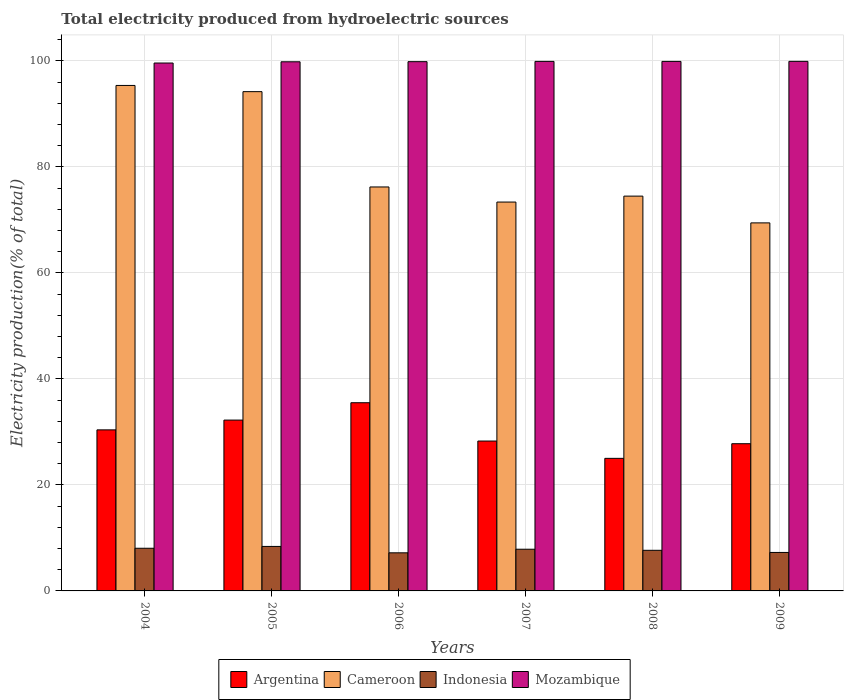How many groups of bars are there?
Make the answer very short. 6. Are the number of bars per tick equal to the number of legend labels?
Offer a terse response. Yes. How many bars are there on the 3rd tick from the left?
Provide a succinct answer. 4. How many bars are there on the 5th tick from the right?
Your response must be concise. 4. What is the label of the 3rd group of bars from the left?
Your answer should be compact. 2006. In how many cases, is the number of bars for a given year not equal to the number of legend labels?
Keep it short and to the point. 0. What is the total electricity produced in Mozambique in 2009?
Ensure brevity in your answer.  99.92. Across all years, what is the maximum total electricity produced in Indonesia?
Your answer should be very brief. 8.4. Across all years, what is the minimum total electricity produced in Argentina?
Your answer should be compact. 25.01. What is the total total electricity produced in Argentina in the graph?
Offer a terse response. 179.21. What is the difference between the total electricity produced in Mozambique in 2004 and that in 2007?
Keep it short and to the point. -0.31. What is the difference between the total electricity produced in Argentina in 2006 and the total electricity produced in Mozambique in 2004?
Ensure brevity in your answer.  -64.1. What is the average total electricity produced in Cameroon per year?
Ensure brevity in your answer.  80.52. In the year 2004, what is the difference between the total electricity produced in Mozambique and total electricity produced in Cameroon?
Provide a succinct answer. 4.23. In how many years, is the total electricity produced in Cameroon greater than 76 %?
Your response must be concise. 3. What is the ratio of the total electricity produced in Argentina in 2004 to that in 2008?
Your answer should be compact. 1.21. Is the total electricity produced in Cameroon in 2005 less than that in 2008?
Ensure brevity in your answer.  No. What is the difference between the highest and the second highest total electricity produced in Indonesia?
Provide a short and direct response. 0.35. What is the difference between the highest and the lowest total electricity produced in Argentina?
Your answer should be very brief. 10.5. In how many years, is the total electricity produced in Indonesia greater than the average total electricity produced in Indonesia taken over all years?
Your answer should be compact. 3. Is the sum of the total electricity produced in Cameroon in 2005 and 2008 greater than the maximum total electricity produced in Mozambique across all years?
Offer a very short reply. Yes. What does the 2nd bar from the left in 2005 represents?
Ensure brevity in your answer.  Cameroon. What does the 1st bar from the right in 2005 represents?
Your answer should be compact. Mozambique. Is it the case that in every year, the sum of the total electricity produced in Mozambique and total electricity produced in Indonesia is greater than the total electricity produced in Cameroon?
Give a very brief answer. Yes. How many bars are there?
Ensure brevity in your answer.  24. Are all the bars in the graph horizontal?
Make the answer very short. No. How many years are there in the graph?
Keep it short and to the point. 6. What is the difference between two consecutive major ticks on the Y-axis?
Give a very brief answer. 20. Are the values on the major ticks of Y-axis written in scientific E-notation?
Your answer should be compact. No. Where does the legend appear in the graph?
Your answer should be very brief. Bottom center. How are the legend labels stacked?
Offer a terse response. Horizontal. What is the title of the graph?
Your answer should be very brief. Total electricity produced from hydroelectric sources. What is the label or title of the Y-axis?
Provide a short and direct response. Electricity production(% of total). What is the Electricity production(% of total) of Argentina in 2004?
Ensure brevity in your answer.  30.39. What is the Electricity production(% of total) in Cameroon in 2004?
Make the answer very short. 95.38. What is the Electricity production(% of total) in Indonesia in 2004?
Provide a succinct answer. 8.05. What is the Electricity production(% of total) in Mozambique in 2004?
Give a very brief answer. 99.61. What is the Electricity production(% of total) of Argentina in 2005?
Provide a short and direct response. 32.23. What is the Electricity production(% of total) in Cameroon in 2005?
Your response must be concise. 94.21. What is the Electricity production(% of total) of Indonesia in 2005?
Your response must be concise. 8.4. What is the Electricity production(% of total) in Mozambique in 2005?
Offer a very short reply. 99.84. What is the Electricity production(% of total) in Argentina in 2006?
Your answer should be compact. 35.51. What is the Electricity production(% of total) of Cameroon in 2006?
Your response must be concise. 76.22. What is the Electricity production(% of total) of Indonesia in 2006?
Ensure brevity in your answer.  7.19. What is the Electricity production(% of total) in Mozambique in 2006?
Ensure brevity in your answer.  99.86. What is the Electricity production(% of total) in Argentina in 2007?
Your answer should be very brief. 28.28. What is the Electricity production(% of total) of Cameroon in 2007?
Offer a very short reply. 73.37. What is the Electricity production(% of total) of Indonesia in 2007?
Ensure brevity in your answer.  7.87. What is the Electricity production(% of total) in Mozambique in 2007?
Make the answer very short. 99.92. What is the Electricity production(% of total) in Argentina in 2008?
Provide a succinct answer. 25.01. What is the Electricity production(% of total) in Cameroon in 2008?
Provide a succinct answer. 74.49. What is the Electricity production(% of total) in Indonesia in 2008?
Provide a short and direct response. 7.66. What is the Electricity production(% of total) in Mozambique in 2008?
Provide a succinct answer. 99.91. What is the Electricity production(% of total) of Argentina in 2009?
Provide a succinct answer. 27.78. What is the Electricity production(% of total) in Cameroon in 2009?
Offer a very short reply. 69.44. What is the Electricity production(% of total) of Indonesia in 2009?
Your answer should be compact. 7.26. What is the Electricity production(% of total) in Mozambique in 2009?
Your answer should be compact. 99.92. Across all years, what is the maximum Electricity production(% of total) in Argentina?
Provide a succinct answer. 35.51. Across all years, what is the maximum Electricity production(% of total) of Cameroon?
Give a very brief answer. 95.38. Across all years, what is the maximum Electricity production(% of total) in Indonesia?
Give a very brief answer. 8.4. Across all years, what is the maximum Electricity production(% of total) in Mozambique?
Keep it short and to the point. 99.92. Across all years, what is the minimum Electricity production(% of total) of Argentina?
Your answer should be very brief. 25.01. Across all years, what is the minimum Electricity production(% of total) in Cameroon?
Provide a succinct answer. 69.44. Across all years, what is the minimum Electricity production(% of total) in Indonesia?
Offer a terse response. 7.19. Across all years, what is the minimum Electricity production(% of total) in Mozambique?
Offer a very short reply. 99.61. What is the total Electricity production(% of total) in Argentina in the graph?
Your answer should be compact. 179.21. What is the total Electricity production(% of total) of Cameroon in the graph?
Keep it short and to the point. 483.12. What is the total Electricity production(% of total) of Indonesia in the graph?
Provide a succinct answer. 46.43. What is the total Electricity production(% of total) of Mozambique in the graph?
Your response must be concise. 599.07. What is the difference between the Electricity production(% of total) of Argentina in 2004 and that in 2005?
Your answer should be very brief. -1.84. What is the difference between the Electricity production(% of total) in Cameroon in 2004 and that in 2005?
Your response must be concise. 1.17. What is the difference between the Electricity production(% of total) in Indonesia in 2004 and that in 2005?
Provide a succinct answer. -0.34. What is the difference between the Electricity production(% of total) in Mozambique in 2004 and that in 2005?
Provide a succinct answer. -0.23. What is the difference between the Electricity production(% of total) of Argentina in 2004 and that in 2006?
Make the answer very short. -5.12. What is the difference between the Electricity production(% of total) of Cameroon in 2004 and that in 2006?
Provide a short and direct response. 19.15. What is the difference between the Electricity production(% of total) in Indonesia in 2004 and that in 2006?
Ensure brevity in your answer.  0.86. What is the difference between the Electricity production(% of total) in Mozambique in 2004 and that in 2006?
Your answer should be compact. -0.26. What is the difference between the Electricity production(% of total) in Argentina in 2004 and that in 2007?
Provide a short and direct response. 2.11. What is the difference between the Electricity production(% of total) of Cameroon in 2004 and that in 2007?
Your answer should be very brief. 22. What is the difference between the Electricity production(% of total) in Indonesia in 2004 and that in 2007?
Your answer should be compact. 0.18. What is the difference between the Electricity production(% of total) of Mozambique in 2004 and that in 2007?
Your answer should be compact. -0.31. What is the difference between the Electricity production(% of total) in Argentina in 2004 and that in 2008?
Offer a terse response. 5.38. What is the difference between the Electricity production(% of total) of Cameroon in 2004 and that in 2008?
Provide a short and direct response. 20.88. What is the difference between the Electricity production(% of total) in Indonesia in 2004 and that in 2008?
Give a very brief answer. 0.39. What is the difference between the Electricity production(% of total) of Mozambique in 2004 and that in 2008?
Provide a succinct answer. -0.31. What is the difference between the Electricity production(% of total) in Argentina in 2004 and that in 2009?
Keep it short and to the point. 2.61. What is the difference between the Electricity production(% of total) of Cameroon in 2004 and that in 2009?
Offer a terse response. 25.93. What is the difference between the Electricity production(% of total) of Indonesia in 2004 and that in 2009?
Ensure brevity in your answer.  0.79. What is the difference between the Electricity production(% of total) in Mozambique in 2004 and that in 2009?
Provide a succinct answer. -0.32. What is the difference between the Electricity production(% of total) of Argentina in 2005 and that in 2006?
Keep it short and to the point. -3.28. What is the difference between the Electricity production(% of total) in Cameroon in 2005 and that in 2006?
Offer a terse response. 17.98. What is the difference between the Electricity production(% of total) in Indonesia in 2005 and that in 2006?
Offer a terse response. 1.21. What is the difference between the Electricity production(% of total) in Mozambique in 2005 and that in 2006?
Ensure brevity in your answer.  -0.02. What is the difference between the Electricity production(% of total) in Argentina in 2005 and that in 2007?
Make the answer very short. 3.95. What is the difference between the Electricity production(% of total) in Cameroon in 2005 and that in 2007?
Ensure brevity in your answer.  20.83. What is the difference between the Electricity production(% of total) of Indonesia in 2005 and that in 2007?
Your response must be concise. 0.53. What is the difference between the Electricity production(% of total) of Mozambique in 2005 and that in 2007?
Keep it short and to the point. -0.08. What is the difference between the Electricity production(% of total) of Argentina in 2005 and that in 2008?
Give a very brief answer. 7.22. What is the difference between the Electricity production(% of total) in Cameroon in 2005 and that in 2008?
Keep it short and to the point. 19.71. What is the difference between the Electricity production(% of total) in Indonesia in 2005 and that in 2008?
Ensure brevity in your answer.  0.73. What is the difference between the Electricity production(% of total) of Mozambique in 2005 and that in 2008?
Offer a terse response. -0.07. What is the difference between the Electricity production(% of total) in Argentina in 2005 and that in 2009?
Your answer should be compact. 4.46. What is the difference between the Electricity production(% of total) of Cameroon in 2005 and that in 2009?
Provide a succinct answer. 24.76. What is the difference between the Electricity production(% of total) in Indonesia in 2005 and that in 2009?
Provide a succinct answer. 1.14. What is the difference between the Electricity production(% of total) of Mozambique in 2005 and that in 2009?
Keep it short and to the point. -0.08. What is the difference between the Electricity production(% of total) in Argentina in 2006 and that in 2007?
Your answer should be very brief. 7.23. What is the difference between the Electricity production(% of total) in Cameroon in 2006 and that in 2007?
Offer a very short reply. 2.85. What is the difference between the Electricity production(% of total) of Indonesia in 2006 and that in 2007?
Give a very brief answer. -0.68. What is the difference between the Electricity production(% of total) of Mozambique in 2006 and that in 2007?
Ensure brevity in your answer.  -0.05. What is the difference between the Electricity production(% of total) of Argentina in 2006 and that in 2008?
Ensure brevity in your answer.  10.5. What is the difference between the Electricity production(% of total) of Cameroon in 2006 and that in 2008?
Ensure brevity in your answer.  1.73. What is the difference between the Electricity production(% of total) of Indonesia in 2006 and that in 2008?
Offer a very short reply. -0.47. What is the difference between the Electricity production(% of total) in Mozambique in 2006 and that in 2008?
Make the answer very short. -0.05. What is the difference between the Electricity production(% of total) in Argentina in 2006 and that in 2009?
Give a very brief answer. 7.73. What is the difference between the Electricity production(% of total) in Cameroon in 2006 and that in 2009?
Provide a short and direct response. 6.78. What is the difference between the Electricity production(% of total) of Indonesia in 2006 and that in 2009?
Make the answer very short. -0.07. What is the difference between the Electricity production(% of total) of Mozambique in 2006 and that in 2009?
Make the answer very short. -0.06. What is the difference between the Electricity production(% of total) in Argentina in 2007 and that in 2008?
Keep it short and to the point. 3.27. What is the difference between the Electricity production(% of total) of Cameroon in 2007 and that in 2008?
Ensure brevity in your answer.  -1.12. What is the difference between the Electricity production(% of total) of Indonesia in 2007 and that in 2008?
Ensure brevity in your answer.  0.2. What is the difference between the Electricity production(% of total) of Mozambique in 2007 and that in 2008?
Your answer should be very brief. 0.01. What is the difference between the Electricity production(% of total) of Argentina in 2007 and that in 2009?
Provide a succinct answer. 0.5. What is the difference between the Electricity production(% of total) in Cameroon in 2007 and that in 2009?
Give a very brief answer. 3.93. What is the difference between the Electricity production(% of total) in Indonesia in 2007 and that in 2009?
Make the answer very short. 0.61. What is the difference between the Electricity production(% of total) in Mozambique in 2007 and that in 2009?
Provide a short and direct response. -0. What is the difference between the Electricity production(% of total) of Argentina in 2008 and that in 2009?
Your answer should be compact. -2.76. What is the difference between the Electricity production(% of total) in Cameroon in 2008 and that in 2009?
Make the answer very short. 5.05. What is the difference between the Electricity production(% of total) in Indonesia in 2008 and that in 2009?
Give a very brief answer. 0.4. What is the difference between the Electricity production(% of total) in Mozambique in 2008 and that in 2009?
Provide a short and direct response. -0.01. What is the difference between the Electricity production(% of total) in Argentina in 2004 and the Electricity production(% of total) in Cameroon in 2005?
Your answer should be compact. -63.82. What is the difference between the Electricity production(% of total) in Argentina in 2004 and the Electricity production(% of total) in Indonesia in 2005?
Offer a terse response. 21.99. What is the difference between the Electricity production(% of total) in Argentina in 2004 and the Electricity production(% of total) in Mozambique in 2005?
Your answer should be very brief. -69.45. What is the difference between the Electricity production(% of total) of Cameroon in 2004 and the Electricity production(% of total) of Indonesia in 2005?
Give a very brief answer. 86.98. What is the difference between the Electricity production(% of total) in Cameroon in 2004 and the Electricity production(% of total) in Mozambique in 2005?
Offer a terse response. -4.46. What is the difference between the Electricity production(% of total) of Indonesia in 2004 and the Electricity production(% of total) of Mozambique in 2005?
Provide a short and direct response. -91.79. What is the difference between the Electricity production(% of total) of Argentina in 2004 and the Electricity production(% of total) of Cameroon in 2006?
Make the answer very short. -45.83. What is the difference between the Electricity production(% of total) of Argentina in 2004 and the Electricity production(% of total) of Indonesia in 2006?
Provide a succinct answer. 23.2. What is the difference between the Electricity production(% of total) of Argentina in 2004 and the Electricity production(% of total) of Mozambique in 2006?
Provide a succinct answer. -69.47. What is the difference between the Electricity production(% of total) of Cameroon in 2004 and the Electricity production(% of total) of Indonesia in 2006?
Offer a terse response. 88.19. What is the difference between the Electricity production(% of total) in Cameroon in 2004 and the Electricity production(% of total) in Mozambique in 2006?
Keep it short and to the point. -4.49. What is the difference between the Electricity production(% of total) of Indonesia in 2004 and the Electricity production(% of total) of Mozambique in 2006?
Your answer should be very brief. -91.81. What is the difference between the Electricity production(% of total) of Argentina in 2004 and the Electricity production(% of total) of Cameroon in 2007?
Offer a very short reply. -42.98. What is the difference between the Electricity production(% of total) of Argentina in 2004 and the Electricity production(% of total) of Indonesia in 2007?
Offer a terse response. 22.52. What is the difference between the Electricity production(% of total) in Argentina in 2004 and the Electricity production(% of total) in Mozambique in 2007?
Provide a succinct answer. -69.53. What is the difference between the Electricity production(% of total) in Cameroon in 2004 and the Electricity production(% of total) in Indonesia in 2007?
Ensure brevity in your answer.  87.51. What is the difference between the Electricity production(% of total) in Cameroon in 2004 and the Electricity production(% of total) in Mozambique in 2007?
Ensure brevity in your answer.  -4.54. What is the difference between the Electricity production(% of total) of Indonesia in 2004 and the Electricity production(% of total) of Mozambique in 2007?
Offer a very short reply. -91.87. What is the difference between the Electricity production(% of total) in Argentina in 2004 and the Electricity production(% of total) in Cameroon in 2008?
Provide a succinct answer. -44.1. What is the difference between the Electricity production(% of total) in Argentina in 2004 and the Electricity production(% of total) in Indonesia in 2008?
Your answer should be compact. 22.73. What is the difference between the Electricity production(% of total) in Argentina in 2004 and the Electricity production(% of total) in Mozambique in 2008?
Make the answer very short. -69.52. What is the difference between the Electricity production(% of total) in Cameroon in 2004 and the Electricity production(% of total) in Indonesia in 2008?
Give a very brief answer. 87.71. What is the difference between the Electricity production(% of total) in Cameroon in 2004 and the Electricity production(% of total) in Mozambique in 2008?
Ensure brevity in your answer.  -4.54. What is the difference between the Electricity production(% of total) in Indonesia in 2004 and the Electricity production(% of total) in Mozambique in 2008?
Provide a succinct answer. -91.86. What is the difference between the Electricity production(% of total) in Argentina in 2004 and the Electricity production(% of total) in Cameroon in 2009?
Your response must be concise. -39.06. What is the difference between the Electricity production(% of total) of Argentina in 2004 and the Electricity production(% of total) of Indonesia in 2009?
Provide a succinct answer. 23.13. What is the difference between the Electricity production(% of total) in Argentina in 2004 and the Electricity production(% of total) in Mozambique in 2009?
Your answer should be very brief. -69.53. What is the difference between the Electricity production(% of total) in Cameroon in 2004 and the Electricity production(% of total) in Indonesia in 2009?
Your answer should be very brief. 88.12. What is the difference between the Electricity production(% of total) of Cameroon in 2004 and the Electricity production(% of total) of Mozambique in 2009?
Make the answer very short. -4.55. What is the difference between the Electricity production(% of total) of Indonesia in 2004 and the Electricity production(% of total) of Mozambique in 2009?
Keep it short and to the point. -91.87. What is the difference between the Electricity production(% of total) of Argentina in 2005 and the Electricity production(% of total) of Cameroon in 2006?
Offer a terse response. -43.99. What is the difference between the Electricity production(% of total) in Argentina in 2005 and the Electricity production(% of total) in Indonesia in 2006?
Your response must be concise. 25.04. What is the difference between the Electricity production(% of total) of Argentina in 2005 and the Electricity production(% of total) of Mozambique in 2006?
Offer a terse response. -67.63. What is the difference between the Electricity production(% of total) of Cameroon in 2005 and the Electricity production(% of total) of Indonesia in 2006?
Keep it short and to the point. 87.02. What is the difference between the Electricity production(% of total) of Cameroon in 2005 and the Electricity production(% of total) of Mozambique in 2006?
Offer a very short reply. -5.66. What is the difference between the Electricity production(% of total) of Indonesia in 2005 and the Electricity production(% of total) of Mozambique in 2006?
Keep it short and to the point. -91.47. What is the difference between the Electricity production(% of total) in Argentina in 2005 and the Electricity production(% of total) in Cameroon in 2007?
Provide a short and direct response. -41.14. What is the difference between the Electricity production(% of total) of Argentina in 2005 and the Electricity production(% of total) of Indonesia in 2007?
Provide a succinct answer. 24.37. What is the difference between the Electricity production(% of total) in Argentina in 2005 and the Electricity production(% of total) in Mozambique in 2007?
Provide a short and direct response. -67.69. What is the difference between the Electricity production(% of total) of Cameroon in 2005 and the Electricity production(% of total) of Indonesia in 2007?
Provide a short and direct response. 86.34. What is the difference between the Electricity production(% of total) in Cameroon in 2005 and the Electricity production(% of total) in Mozambique in 2007?
Offer a terse response. -5.71. What is the difference between the Electricity production(% of total) in Indonesia in 2005 and the Electricity production(% of total) in Mozambique in 2007?
Give a very brief answer. -91.52. What is the difference between the Electricity production(% of total) of Argentina in 2005 and the Electricity production(% of total) of Cameroon in 2008?
Give a very brief answer. -42.26. What is the difference between the Electricity production(% of total) in Argentina in 2005 and the Electricity production(% of total) in Indonesia in 2008?
Offer a terse response. 24.57. What is the difference between the Electricity production(% of total) in Argentina in 2005 and the Electricity production(% of total) in Mozambique in 2008?
Your response must be concise. -67.68. What is the difference between the Electricity production(% of total) in Cameroon in 2005 and the Electricity production(% of total) in Indonesia in 2008?
Your answer should be very brief. 86.54. What is the difference between the Electricity production(% of total) of Cameroon in 2005 and the Electricity production(% of total) of Mozambique in 2008?
Provide a succinct answer. -5.71. What is the difference between the Electricity production(% of total) in Indonesia in 2005 and the Electricity production(% of total) in Mozambique in 2008?
Your answer should be very brief. -91.52. What is the difference between the Electricity production(% of total) of Argentina in 2005 and the Electricity production(% of total) of Cameroon in 2009?
Provide a short and direct response. -37.21. What is the difference between the Electricity production(% of total) of Argentina in 2005 and the Electricity production(% of total) of Indonesia in 2009?
Your answer should be compact. 24.97. What is the difference between the Electricity production(% of total) of Argentina in 2005 and the Electricity production(% of total) of Mozambique in 2009?
Your response must be concise. -67.69. What is the difference between the Electricity production(% of total) of Cameroon in 2005 and the Electricity production(% of total) of Indonesia in 2009?
Provide a short and direct response. 86.95. What is the difference between the Electricity production(% of total) in Cameroon in 2005 and the Electricity production(% of total) in Mozambique in 2009?
Make the answer very short. -5.72. What is the difference between the Electricity production(% of total) in Indonesia in 2005 and the Electricity production(% of total) in Mozambique in 2009?
Your answer should be very brief. -91.53. What is the difference between the Electricity production(% of total) in Argentina in 2006 and the Electricity production(% of total) in Cameroon in 2007?
Offer a terse response. -37.86. What is the difference between the Electricity production(% of total) in Argentina in 2006 and the Electricity production(% of total) in Indonesia in 2007?
Offer a terse response. 27.64. What is the difference between the Electricity production(% of total) in Argentina in 2006 and the Electricity production(% of total) in Mozambique in 2007?
Give a very brief answer. -64.41. What is the difference between the Electricity production(% of total) in Cameroon in 2006 and the Electricity production(% of total) in Indonesia in 2007?
Give a very brief answer. 68.36. What is the difference between the Electricity production(% of total) in Cameroon in 2006 and the Electricity production(% of total) in Mozambique in 2007?
Your answer should be very brief. -23.7. What is the difference between the Electricity production(% of total) of Indonesia in 2006 and the Electricity production(% of total) of Mozambique in 2007?
Provide a short and direct response. -92.73. What is the difference between the Electricity production(% of total) of Argentina in 2006 and the Electricity production(% of total) of Cameroon in 2008?
Ensure brevity in your answer.  -38.98. What is the difference between the Electricity production(% of total) of Argentina in 2006 and the Electricity production(% of total) of Indonesia in 2008?
Provide a succinct answer. 27.85. What is the difference between the Electricity production(% of total) in Argentina in 2006 and the Electricity production(% of total) in Mozambique in 2008?
Ensure brevity in your answer.  -64.4. What is the difference between the Electricity production(% of total) of Cameroon in 2006 and the Electricity production(% of total) of Indonesia in 2008?
Give a very brief answer. 68.56. What is the difference between the Electricity production(% of total) in Cameroon in 2006 and the Electricity production(% of total) in Mozambique in 2008?
Provide a short and direct response. -23.69. What is the difference between the Electricity production(% of total) in Indonesia in 2006 and the Electricity production(% of total) in Mozambique in 2008?
Your answer should be very brief. -92.72. What is the difference between the Electricity production(% of total) in Argentina in 2006 and the Electricity production(% of total) in Cameroon in 2009?
Give a very brief answer. -33.93. What is the difference between the Electricity production(% of total) of Argentina in 2006 and the Electricity production(% of total) of Indonesia in 2009?
Make the answer very short. 28.25. What is the difference between the Electricity production(% of total) of Argentina in 2006 and the Electricity production(% of total) of Mozambique in 2009?
Keep it short and to the point. -64.41. What is the difference between the Electricity production(% of total) in Cameroon in 2006 and the Electricity production(% of total) in Indonesia in 2009?
Your answer should be very brief. 68.96. What is the difference between the Electricity production(% of total) in Cameroon in 2006 and the Electricity production(% of total) in Mozambique in 2009?
Provide a short and direct response. -23.7. What is the difference between the Electricity production(% of total) in Indonesia in 2006 and the Electricity production(% of total) in Mozambique in 2009?
Your response must be concise. -92.73. What is the difference between the Electricity production(% of total) in Argentina in 2007 and the Electricity production(% of total) in Cameroon in 2008?
Provide a short and direct response. -46.21. What is the difference between the Electricity production(% of total) in Argentina in 2007 and the Electricity production(% of total) in Indonesia in 2008?
Your response must be concise. 20.62. What is the difference between the Electricity production(% of total) of Argentina in 2007 and the Electricity production(% of total) of Mozambique in 2008?
Provide a succinct answer. -71.63. What is the difference between the Electricity production(% of total) of Cameroon in 2007 and the Electricity production(% of total) of Indonesia in 2008?
Keep it short and to the point. 65.71. What is the difference between the Electricity production(% of total) of Cameroon in 2007 and the Electricity production(% of total) of Mozambique in 2008?
Your answer should be compact. -26.54. What is the difference between the Electricity production(% of total) of Indonesia in 2007 and the Electricity production(% of total) of Mozambique in 2008?
Give a very brief answer. -92.05. What is the difference between the Electricity production(% of total) in Argentina in 2007 and the Electricity production(% of total) in Cameroon in 2009?
Ensure brevity in your answer.  -41.16. What is the difference between the Electricity production(% of total) in Argentina in 2007 and the Electricity production(% of total) in Indonesia in 2009?
Your answer should be very brief. 21.02. What is the difference between the Electricity production(% of total) of Argentina in 2007 and the Electricity production(% of total) of Mozambique in 2009?
Provide a succinct answer. -71.64. What is the difference between the Electricity production(% of total) in Cameroon in 2007 and the Electricity production(% of total) in Indonesia in 2009?
Make the answer very short. 66.11. What is the difference between the Electricity production(% of total) of Cameroon in 2007 and the Electricity production(% of total) of Mozambique in 2009?
Your answer should be very brief. -26.55. What is the difference between the Electricity production(% of total) of Indonesia in 2007 and the Electricity production(% of total) of Mozambique in 2009?
Give a very brief answer. -92.06. What is the difference between the Electricity production(% of total) in Argentina in 2008 and the Electricity production(% of total) in Cameroon in 2009?
Provide a succinct answer. -44.43. What is the difference between the Electricity production(% of total) of Argentina in 2008 and the Electricity production(% of total) of Indonesia in 2009?
Offer a very short reply. 17.75. What is the difference between the Electricity production(% of total) in Argentina in 2008 and the Electricity production(% of total) in Mozambique in 2009?
Offer a terse response. -74.91. What is the difference between the Electricity production(% of total) in Cameroon in 2008 and the Electricity production(% of total) in Indonesia in 2009?
Provide a short and direct response. 67.23. What is the difference between the Electricity production(% of total) in Cameroon in 2008 and the Electricity production(% of total) in Mozambique in 2009?
Give a very brief answer. -25.43. What is the difference between the Electricity production(% of total) in Indonesia in 2008 and the Electricity production(% of total) in Mozambique in 2009?
Make the answer very short. -92.26. What is the average Electricity production(% of total) of Argentina per year?
Make the answer very short. 29.87. What is the average Electricity production(% of total) in Cameroon per year?
Your answer should be very brief. 80.52. What is the average Electricity production(% of total) in Indonesia per year?
Make the answer very short. 7.74. What is the average Electricity production(% of total) in Mozambique per year?
Provide a succinct answer. 99.84. In the year 2004, what is the difference between the Electricity production(% of total) of Argentina and Electricity production(% of total) of Cameroon?
Keep it short and to the point. -64.99. In the year 2004, what is the difference between the Electricity production(% of total) of Argentina and Electricity production(% of total) of Indonesia?
Give a very brief answer. 22.34. In the year 2004, what is the difference between the Electricity production(% of total) of Argentina and Electricity production(% of total) of Mozambique?
Your answer should be compact. -69.22. In the year 2004, what is the difference between the Electricity production(% of total) in Cameroon and Electricity production(% of total) in Indonesia?
Your answer should be compact. 87.33. In the year 2004, what is the difference between the Electricity production(% of total) in Cameroon and Electricity production(% of total) in Mozambique?
Your answer should be very brief. -4.23. In the year 2004, what is the difference between the Electricity production(% of total) of Indonesia and Electricity production(% of total) of Mozambique?
Your response must be concise. -91.56. In the year 2005, what is the difference between the Electricity production(% of total) in Argentina and Electricity production(% of total) in Cameroon?
Offer a very short reply. -61.97. In the year 2005, what is the difference between the Electricity production(% of total) of Argentina and Electricity production(% of total) of Indonesia?
Give a very brief answer. 23.84. In the year 2005, what is the difference between the Electricity production(% of total) of Argentina and Electricity production(% of total) of Mozambique?
Offer a very short reply. -67.61. In the year 2005, what is the difference between the Electricity production(% of total) in Cameroon and Electricity production(% of total) in Indonesia?
Your answer should be very brief. 85.81. In the year 2005, what is the difference between the Electricity production(% of total) in Cameroon and Electricity production(% of total) in Mozambique?
Offer a terse response. -5.64. In the year 2005, what is the difference between the Electricity production(% of total) in Indonesia and Electricity production(% of total) in Mozambique?
Provide a succinct answer. -91.45. In the year 2006, what is the difference between the Electricity production(% of total) of Argentina and Electricity production(% of total) of Cameroon?
Make the answer very short. -40.71. In the year 2006, what is the difference between the Electricity production(% of total) of Argentina and Electricity production(% of total) of Indonesia?
Your response must be concise. 28.32. In the year 2006, what is the difference between the Electricity production(% of total) of Argentina and Electricity production(% of total) of Mozambique?
Your answer should be compact. -64.35. In the year 2006, what is the difference between the Electricity production(% of total) in Cameroon and Electricity production(% of total) in Indonesia?
Offer a terse response. 69.03. In the year 2006, what is the difference between the Electricity production(% of total) of Cameroon and Electricity production(% of total) of Mozambique?
Make the answer very short. -23.64. In the year 2006, what is the difference between the Electricity production(% of total) in Indonesia and Electricity production(% of total) in Mozambique?
Offer a terse response. -92.67. In the year 2007, what is the difference between the Electricity production(% of total) in Argentina and Electricity production(% of total) in Cameroon?
Offer a very short reply. -45.09. In the year 2007, what is the difference between the Electricity production(% of total) of Argentina and Electricity production(% of total) of Indonesia?
Make the answer very short. 20.42. In the year 2007, what is the difference between the Electricity production(% of total) of Argentina and Electricity production(% of total) of Mozambique?
Give a very brief answer. -71.64. In the year 2007, what is the difference between the Electricity production(% of total) of Cameroon and Electricity production(% of total) of Indonesia?
Your answer should be very brief. 65.51. In the year 2007, what is the difference between the Electricity production(% of total) of Cameroon and Electricity production(% of total) of Mozambique?
Provide a succinct answer. -26.55. In the year 2007, what is the difference between the Electricity production(% of total) of Indonesia and Electricity production(% of total) of Mozambique?
Offer a very short reply. -92.05. In the year 2008, what is the difference between the Electricity production(% of total) of Argentina and Electricity production(% of total) of Cameroon?
Offer a very short reply. -49.48. In the year 2008, what is the difference between the Electricity production(% of total) in Argentina and Electricity production(% of total) in Indonesia?
Your answer should be compact. 17.35. In the year 2008, what is the difference between the Electricity production(% of total) in Argentina and Electricity production(% of total) in Mozambique?
Offer a terse response. -74.9. In the year 2008, what is the difference between the Electricity production(% of total) of Cameroon and Electricity production(% of total) of Indonesia?
Ensure brevity in your answer.  66.83. In the year 2008, what is the difference between the Electricity production(% of total) in Cameroon and Electricity production(% of total) in Mozambique?
Offer a very short reply. -25.42. In the year 2008, what is the difference between the Electricity production(% of total) of Indonesia and Electricity production(% of total) of Mozambique?
Make the answer very short. -92.25. In the year 2009, what is the difference between the Electricity production(% of total) in Argentina and Electricity production(% of total) in Cameroon?
Offer a terse response. -41.67. In the year 2009, what is the difference between the Electricity production(% of total) in Argentina and Electricity production(% of total) in Indonesia?
Make the answer very short. 20.52. In the year 2009, what is the difference between the Electricity production(% of total) in Argentina and Electricity production(% of total) in Mozambique?
Your response must be concise. -72.15. In the year 2009, what is the difference between the Electricity production(% of total) of Cameroon and Electricity production(% of total) of Indonesia?
Keep it short and to the point. 62.18. In the year 2009, what is the difference between the Electricity production(% of total) in Cameroon and Electricity production(% of total) in Mozambique?
Provide a succinct answer. -30.48. In the year 2009, what is the difference between the Electricity production(% of total) in Indonesia and Electricity production(% of total) in Mozambique?
Make the answer very short. -92.66. What is the ratio of the Electricity production(% of total) in Argentina in 2004 to that in 2005?
Keep it short and to the point. 0.94. What is the ratio of the Electricity production(% of total) of Cameroon in 2004 to that in 2005?
Your answer should be compact. 1.01. What is the ratio of the Electricity production(% of total) in Indonesia in 2004 to that in 2005?
Ensure brevity in your answer.  0.96. What is the ratio of the Electricity production(% of total) in Argentina in 2004 to that in 2006?
Offer a very short reply. 0.86. What is the ratio of the Electricity production(% of total) of Cameroon in 2004 to that in 2006?
Offer a very short reply. 1.25. What is the ratio of the Electricity production(% of total) of Indonesia in 2004 to that in 2006?
Make the answer very short. 1.12. What is the ratio of the Electricity production(% of total) in Argentina in 2004 to that in 2007?
Your answer should be very brief. 1.07. What is the ratio of the Electricity production(% of total) in Cameroon in 2004 to that in 2007?
Offer a terse response. 1.3. What is the ratio of the Electricity production(% of total) in Indonesia in 2004 to that in 2007?
Your answer should be compact. 1.02. What is the ratio of the Electricity production(% of total) of Mozambique in 2004 to that in 2007?
Ensure brevity in your answer.  1. What is the ratio of the Electricity production(% of total) of Argentina in 2004 to that in 2008?
Your answer should be compact. 1.22. What is the ratio of the Electricity production(% of total) of Cameroon in 2004 to that in 2008?
Give a very brief answer. 1.28. What is the ratio of the Electricity production(% of total) in Indonesia in 2004 to that in 2008?
Your answer should be very brief. 1.05. What is the ratio of the Electricity production(% of total) in Argentina in 2004 to that in 2009?
Your answer should be compact. 1.09. What is the ratio of the Electricity production(% of total) of Cameroon in 2004 to that in 2009?
Offer a very short reply. 1.37. What is the ratio of the Electricity production(% of total) in Indonesia in 2004 to that in 2009?
Offer a very short reply. 1.11. What is the ratio of the Electricity production(% of total) in Mozambique in 2004 to that in 2009?
Make the answer very short. 1. What is the ratio of the Electricity production(% of total) of Argentina in 2005 to that in 2006?
Offer a very short reply. 0.91. What is the ratio of the Electricity production(% of total) in Cameroon in 2005 to that in 2006?
Give a very brief answer. 1.24. What is the ratio of the Electricity production(% of total) in Indonesia in 2005 to that in 2006?
Offer a very short reply. 1.17. What is the ratio of the Electricity production(% of total) in Argentina in 2005 to that in 2007?
Offer a terse response. 1.14. What is the ratio of the Electricity production(% of total) in Cameroon in 2005 to that in 2007?
Your response must be concise. 1.28. What is the ratio of the Electricity production(% of total) in Indonesia in 2005 to that in 2007?
Your answer should be compact. 1.07. What is the ratio of the Electricity production(% of total) of Argentina in 2005 to that in 2008?
Provide a short and direct response. 1.29. What is the ratio of the Electricity production(% of total) in Cameroon in 2005 to that in 2008?
Your answer should be very brief. 1.26. What is the ratio of the Electricity production(% of total) of Indonesia in 2005 to that in 2008?
Your answer should be compact. 1.1. What is the ratio of the Electricity production(% of total) in Mozambique in 2005 to that in 2008?
Give a very brief answer. 1. What is the ratio of the Electricity production(% of total) in Argentina in 2005 to that in 2009?
Provide a short and direct response. 1.16. What is the ratio of the Electricity production(% of total) in Cameroon in 2005 to that in 2009?
Ensure brevity in your answer.  1.36. What is the ratio of the Electricity production(% of total) in Indonesia in 2005 to that in 2009?
Your answer should be very brief. 1.16. What is the ratio of the Electricity production(% of total) in Mozambique in 2005 to that in 2009?
Give a very brief answer. 1. What is the ratio of the Electricity production(% of total) of Argentina in 2006 to that in 2007?
Your answer should be compact. 1.26. What is the ratio of the Electricity production(% of total) in Cameroon in 2006 to that in 2007?
Give a very brief answer. 1.04. What is the ratio of the Electricity production(% of total) in Indonesia in 2006 to that in 2007?
Your response must be concise. 0.91. What is the ratio of the Electricity production(% of total) of Argentina in 2006 to that in 2008?
Keep it short and to the point. 1.42. What is the ratio of the Electricity production(% of total) in Cameroon in 2006 to that in 2008?
Offer a very short reply. 1.02. What is the ratio of the Electricity production(% of total) of Indonesia in 2006 to that in 2008?
Make the answer very short. 0.94. What is the ratio of the Electricity production(% of total) of Argentina in 2006 to that in 2009?
Give a very brief answer. 1.28. What is the ratio of the Electricity production(% of total) of Cameroon in 2006 to that in 2009?
Keep it short and to the point. 1.1. What is the ratio of the Electricity production(% of total) in Indonesia in 2006 to that in 2009?
Ensure brevity in your answer.  0.99. What is the ratio of the Electricity production(% of total) of Argentina in 2007 to that in 2008?
Your answer should be very brief. 1.13. What is the ratio of the Electricity production(% of total) of Indonesia in 2007 to that in 2008?
Ensure brevity in your answer.  1.03. What is the ratio of the Electricity production(% of total) in Argentina in 2007 to that in 2009?
Your response must be concise. 1.02. What is the ratio of the Electricity production(% of total) in Cameroon in 2007 to that in 2009?
Provide a short and direct response. 1.06. What is the ratio of the Electricity production(% of total) in Indonesia in 2007 to that in 2009?
Your answer should be compact. 1.08. What is the ratio of the Electricity production(% of total) in Argentina in 2008 to that in 2009?
Offer a very short reply. 0.9. What is the ratio of the Electricity production(% of total) in Cameroon in 2008 to that in 2009?
Give a very brief answer. 1.07. What is the ratio of the Electricity production(% of total) of Indonesia in 2008 to that in 2009?
Keep it short and to the point. 1.06. What is the difference between the highest and the second highest Electricity production(% of total) in Argentina?
Ensure brevity in your answer.  3.28. What is the difference between the highest and the second highest Electricity production(% of total) of Cameroon?
Offer a terse response. 1.17. What is the difference between the highest and the second highest Electricity production(% of total) in Indonesia?
Your answer should be compact. 0.34. What is the difference between the highest and the second highest Electricity production(% of total) of Mozambique?
Offer a very short reply. 0. What is the difference between the highest and the lowest Electricity production(% of total) of Argentina?
Keep it short and to the point. 10.5. What is the difference between the highest and the lowest Electricity production(% of total) of Cameroon?
Provide a short and direct response. 25.93. What is the difference between the highest and the lowest Electricity production(% of total) of Indonesia?
Keep it short and to the point. 1.21. What is the difference between the highest and the lowest Electricity production(% of total) of Mozambique?
Ensure brevity in your answer.  0.32. 